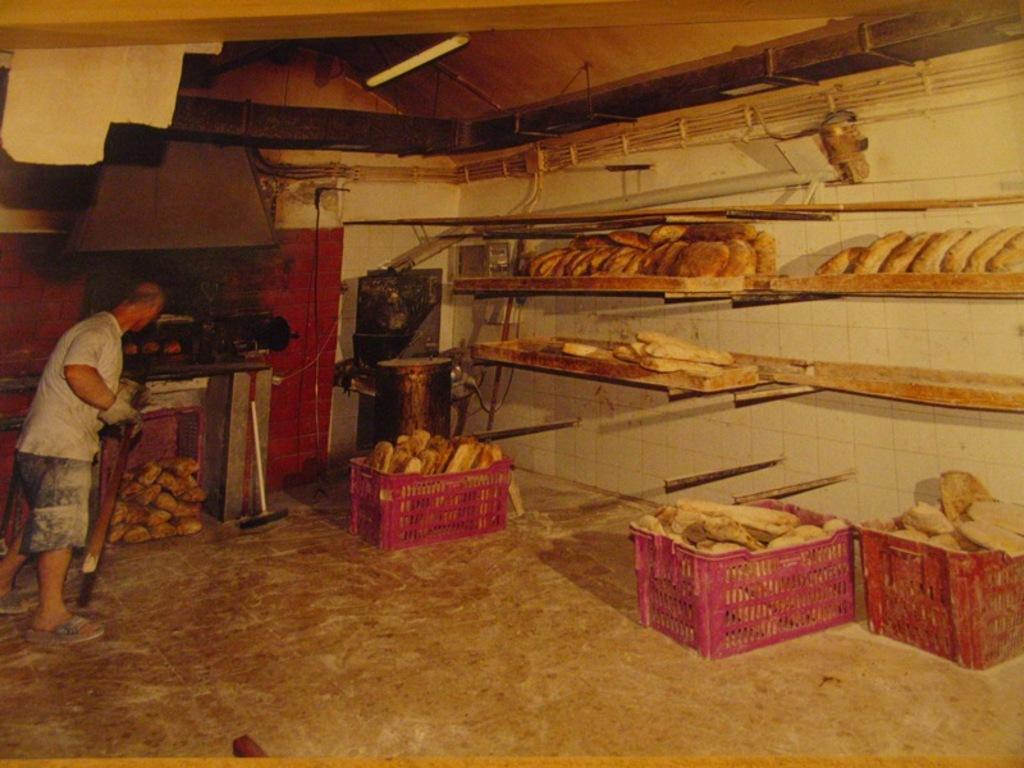What is the main subject of the image? There is a person in the image. What is the person holding in their hand? The person is holding a stick in their hand. Where is the person standing? The person is standing on the floor. What can be seen on the floor or ground in the image? There are baskets in the image. What type of structure is visible in the image? There are shelves in the image, and a roof is visible. What else can be seen in the image besides the person and the baskets? There are objects in the image, and the walls are visible in the background. What type of rifle is the person using in the image? There is no rifle present in the image; the person is holding a stick. What role does the person play in the war depicted in the image? There is no war depicted in the image; it features a person holding a stick and standing near baskets and shelves. 